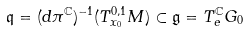<formula> <loc_0><loc_0><loc_500><loc_500>\mathfrak { q } = ( d \pi ^ { \mathbb { C } } ) ^ { - 1 } ( T ^ { 0 , 1 } _ { x _ { 0 } } M ) \subset { \mathfrak { g } } = T ^ { \mathbb { C } } _ { e } { G _ { 0 } }</formula> 